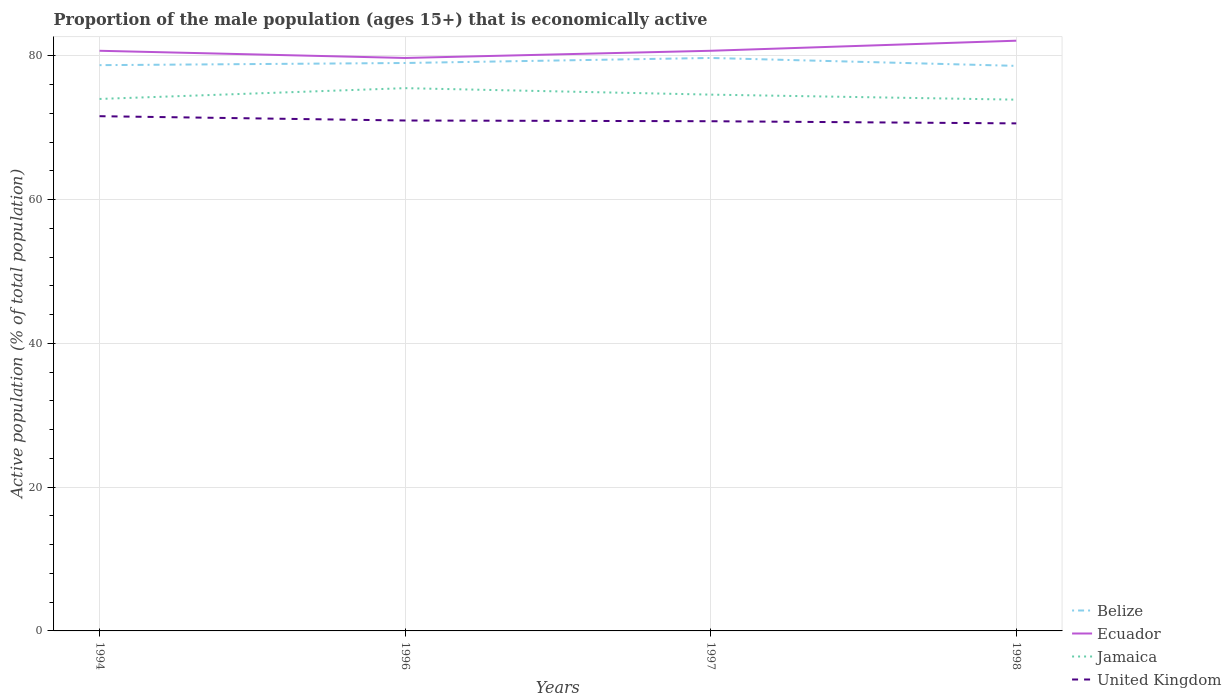How many different coloured lines are there?
Your answer should be compact. 4. Does the line corresponding to Belize intersect with the line corresponding to United Kingdom?
Ensure brevity in your answer.  No. Across all years, what is the maximum proportion of the male population that is economically active in Ecuador?
Offer a terse response. 79.7. In which year was the proportion of the male population that is economically active in Jamaica maximum?
Your answer should be compact. 1998. What is the total proportion of the male population that is economically active in Jamaica in the graph?
Provide a succinct answer. 0.1. What is the difference between the highest and the second highest proportion of the male population that is economically active in Belize?
Keep it short and to the point. 1.1. What is the difference between the highest and the lowest proportion of the male population that is economically active in Ecuador?
Your response must be concise. 1. Is the proportion of the male population that is economically active in Jamaica strictly greater than the proportion of the male population that is economically active in Ecuador over the years?
Your response must be concise. Yes. Are the values on the major ticks of Y-axis written in scientific E-notation?
Your answer should be very brief. No. Does the graph contain any zero values?
Offer a terse response. No. How are the legend labels stacked?
Offer a very short reply. Vertical. What is the title of the graph?
Make the answer very short. Proportion of the male population (ages 15+) that is economically active. What is the label or title of the Y-axis?
Your response must be concise. Active population (% of total population). What is the Active population (% of total population) in Belize in 1994?
Your answer should be compact. 78.7. What is the Active population (% of total population) of Ecuador in 1994?
Offer a very short reply. 80.7. What is the Active population (% of total population) in Jamaica in 1994?
Give a very brief answer. 74. What is the Active population (% of total population) in United Kingdom in 1994?
Keep it short and to the point. 71.6. What is the Active population (% of total population) of Belize in 1996?
Offer a very short reply. 79. What is the Active population (% of total population) of Ecuador in 1996?
Offer a terse response. 79.7. What is the Active population (% of total population) of Jamaica in 1996?
Offer a terse response. 75.5. What is the Active population (% of total population) in Belize in 1997?
Provide a succinct answer. 79.7. What is the Active population (% of total population) in Ecuador in 1997?
Provide a succinct answer. 80.7. What is the Active population (% of total population) in Jamaica in 1997?
Ensure brevity in your answer.  74.6. What is the Active population (% of total population) of United Kingdom in 1997?
Provide a short and direct response. 70.9. What is the Active population (% of total population) in Belize in 1998?
Offer a terse response. 78.6. What is the Active population (% of total population) in Ecuador in 1998?
Your answer should be very brief. 82.1. What is the Active population (% of total population) of Jamaica in 1998?
Offer a very short reply. 73.9. What is the Active population (% of total population) of United Kingdom in 1998?
Offer a very short reply. 70.6. Across all years, what is the maximum Active population (% of total population) of Belize?
Offer a terse response. 79.7. Across all years, what is the maximum Active population (% of total population) of Ecuador?
Your response must be concise. 82.1. Across all years, what is the maximum Active population (% of total population) in Jamaica?
Offer a very short reply. 75.5. Across all years, what is the maximum Active population (% of total population) of United Kingdom?
Give a very brief answer. 71.6. Across all years, what is the minimum Active population (% of total population) in Belize?
Your answer should be very brief. 78.6. Across all years, what is the minimum Active population (% of total population) of Ecuador?
Your answer should be very brief. 79.7. Across all years, what is the minimum Active population (% of total population) in Jamaica?
Make the answer very short. 73.9. Across all years, what is the minimum Active population (% of total population) of United Kingdom?
Your answer should be very brief. 70.6. What is the total Active population (% of total population) in Belize in the graph?
Keep it short and to the point. 316. What is the total Active population (% of total population) of Ecuador in the graph?
Provide a short and direct response. 323.2. What is the total Active population (% of total population) of Jamaica in the graph?
Make the answer very short. 298. What is the total Active population (% of total population) in United Kingdom in the graph?
Offer a very short reply. 284.1. What is the difference between the Active population (% of total population) in Belize in 1994 and that in 1996?
Provide a short and direct response. -0.3. What is the difference between the Active population (% of total population) in Jamaica in 1994 and that in 1996?
Offer a terse response. -1.5. What is the difference between the Active population (% of total population) of United Kingdom in 1994 and that in 1996?
Provide a short and direct response. 0.6. What is the difference between the Active population (% of total population) in Ecuador in 1994 and that in 1997?
Your answer should be compact. 0. What is the difference between the Active population (% of total population) in Jamaica in 1994 and that in 1997?
Offer a very short reply. -0.6. What is the difference between the Active population (% of total population) of United Kingdom in 1994 and that in 1998?
Your answer should be very brief. 1. What is the difference between the Active population (% of total population) in Belize in 1996 and that in 1997?
Your response must be concise. -0.7. What is the difference between the Active population (% of total population) in Jamaica in 1996 and that in 1997?
Keep it short and to the point. 0.9. What is the difference between the Active population (% of total population) of Belize in 1996 and that in 1998?
Provide a short and direct response. 0.4. What is the difference between the Active population (% of total population) of Ecuador in 1996 and that in 1998?
Ensure brevity in your answer.  -2.4. What is the difference between the Active population (% of total population) of United Kingdom in 1996 and that in 1998?
Ensure brevity in your answer.  0.4. What is the difference between the Active population (% of total population) of Belize in 1997 and that in 1998?
Ensure brevity in your answer.  1.1. What is the difference between the Active population (% of total population) in Jamaica in 1997 and that in 1998?
Keep it short and to the point. 0.7. What is the difference between the Active population (% of total population) in United Kingdom in 1997 and that in 1998?
Ensure brevity in your answer.  0.3. What is the difference between the Active population (% of total population) of Belize in 1994 and the Active population (% of total population) of United Kingdom in 1996?
Provide a short and direct response. 7.7. What is the difference between the Active population (% of total population) in Jamaica in 1994 and the Active population (% of total population) in United Kingdom in 1996?
Your answer should be very brief. 3. What is the difference between the Active population (% of total population) in Belize in 1994 and the Active population (% of total population) in United Kingdom in 1997?
Your response must be concise. 7.8. What is the difference between the Active population (% of total population) of Jamaica in 1994 and the Active population (% of total population) of United Kingdom in 1997?
Provide a succinct answer. 3.1. What is the difference between the Active population (% of total population) of Belize in 1994 and the Active population (% of total population) of Ecuador in 1998?
Give a very brief answer. -3.4. What is the difference between the Active population (% of total population) in Ecuador in 1994 and the Active population (% of total population) in United Kingdom in 1998?
Ensure brevity in your answer.  10.1. What is the difference between the Active population (% of total population) of Belize in 1996 and the Active population (% of total population) of Jamaica in 1997?
Offer a terse response. 4.4. What is the difference between the Active population (% of total population) in Belize in 1996 and the Active population (% of total population) in United Kingdom in 1997?
Your response must be concise. 8.1. What is the difference between the Active population (% of total population) in Ecuador in 1996 and the Active population (% of total population) in United Kingdom in 1997?
Ensure brevity in your answer.  8.8. What is the difference between the Active population (% of total population) in Belize in 1996 and the Active population (% of total population) in Jamaica in 1998?
Your response must be concise. 5.1. What is the difference between the Active population (% of total population) in Belize in 1996 and the Active population (% of total population) in United Kingdom in 1998?
Offer a very short reply. 8.4. What is the difference between the Active population (% of total population) of Ecuador in 1996 and the Active population (% of total population) of United Kingdom in 1998?
Offer a very short reply. 9.1. What is the difference between the Active population (% of total population) of Belize in 1997 and the Active population (% of total population) of Ecuador in 1998?
Make the answer very short. -2.4. What is the difference between the Active population (% of total population) in Belize in 1997 and the Active population (% of total population) in Jamaica in 1998?
Make the answer very short. 5.8. What is the difference between the Active population (% of total population) in Ecuador in 1997 and the Active population (% of total population) in Jamaica in 1998?
Your answer should be compact. 6.8. What is the difference between the Active population (% of total population) of Jamaica in 1997 and the Active population (% of total population) of United Kingdom in 1998?
Your response must be concise. 4. What is the average Active population (% of total population) in Belize per year?
Provide a succinct answer. 79. What is the average Active population (% of total population) of Ecuador per year?
Offer a terse response. 80.8. What is the average Active population (% of total population) of Jamaica per year?
Offer a terse response. 74.5. What is the average Active population (% of total population) in United Kingdom per year?
Ensure brevity in your answer.  71.03. In the year 1994, what is the difference between the Active population (% of total population) in Belize and Active population (% of total population) in Ecuador?
Make the answer very short. -2. In the year 1994, what is the difference between the Active population (% of total population) in Belize and Active population (% of total population) in Jamaica?
Ensure brevity in your answer.  4.7. In the year 1994, what is the difference between the Active population (% of total population) of Jamaica and Active population (% of total population) of United Kingdom?
Give a very brief answer. 2.4. In the year 1996, what is the difference between the Active population (% of total population) of Belize and Active population (% of total population) of Ecuador?
Offer a terse response. -0.7. In the year 1996, what is the difference between the Active population (% of total population) in Belize and Active population (% of total population) in Jamaica?
Ensure brevity in your answer.  3.5. In the year 1996, what is the difference between the Active population (% of total population) in Belize and Active population (% of total population) in United Kingdom?
Give a very brief answer. 8. In the year 1996, what is the difference between the Active population (% of total population) of Ecuador and Active population (% of total population) of Jamaica?
Make the answer very short. 4.2. In the year 1996, what is the difference between the Active population (% of total population) of Ecuador and Active population (% of total population) of United Kingdom?
Give a very brief answer. 8.7. In the year 1996, what is the difference between the Active population (% of total population) of Jamaica and Active population (% of total population) of United Kingdom?
Give a very brief answer. 4.5. In the year 1997, what is the difference between the Active population (% of total population) in Belize and Active population (% of total population) in Jamaica?
Provide a succinct answer. 5.1. In the year 1997, what is the difference between the Active population (% of total population) in Belize and Active population (% of total population) in United Kingdom?
Your answer should be very brief. 8.8. In the year 1997, what is the difference between the Active population (% of total population) in Ecuador and Active population (% of total population) in Jamaica?
Give a very brief answer. 6.1. In the year 1997, what is the difference between the Active population (% of total population) in Jamaica and Active population (% of total population) in United Kingdom?
Provide a succinct answer. 3.7. In the year 1998, what is the difference between the Active population (% of total population) of Belize and Active population (% of total population) of Ecuador?
Make the answer very short. -3.5. In the year 1998, what is the difference between the Active population (% of total population) of Jamaica and Active population (% of total population) of United Kingdom?
Offer a very short reply. 3.3. What is the ratio of the Active population (% of total population) of Belize in 1994 to that in 1996?
Ensure brevity in your answer.  1. What is the ratio of the Active population (% of total population) in Ecuador in 1994 to that in 1996?
Your answer should be very brief. 1.01. What is the ratio of the Active population (% of total population) of Jamaica in 1994 to that in 1996?
Give a very brief answer. 0.98. What is the ratio of the Active population (% of total population) in United Kingdom in 1994 to that in 1996?
Provide a short and direct response. 1.01. What is the ratio of the Active population (% of total population) in Belize in 1994 to that in 1997?
Offer a very short reply. 0.99. What is the ratio of the Active population (% of total population) in Ecuador in 1994 to that in 1997?
Offer a terse response. 1. What is the ratio of the Active population (% of total population) of Jamaica in 1994 to that in 1997?
Keep it short and to the point. 0.99. What is the ratio of the Active population (% of total population) of United Kingdom in 1994 to that in 1997?
Your answer should be very brief. 1.01. What is the ratio of the Active population (% of total population) in Belize in 1994 to that in 1998?
Your response must be concise. 1. What is the ratio of the Active population (% of total population) in Ecuador in 1994 to that in 1998?
Ensure brevity in your answer.  0.98. What is the ratio of the Active population (% of total population) of Jamaica in 1994 to that in 1998?
Make the answer very short. 1. What is the ratio of the Active population (% of total population) of United Kingdom in 1994 to that in 1998?
Give a very brief answer. 1.01. What is the ratio of the Active population (% of total population) of Ecuador in 1996 to that in 1997?
Keep it short and to the point. 0.99. What is the ratio of the Active population (% of total population) in Jamaica in 1996 to that in 1997?
Ensure brevity in your answer.  1.01. What is the ratio of the Active population (% of total population) in United Kingdom in 1996 to that in 1997?
Give a very brief answer. 1. What is the ratio of the Active population (% of total population) in Ecuador in 1996 to that in 1998?
Your answer should be very brief. 0.97. What is the ratio of the Active population (% of total population) of Jamaica in 1996 to that in 1998?
Offer a very short reply. 1.02. What is the ratio of the Active population (% of total population) in United Kingdom in 1996 to that in 1998?
Your response must be concise. 1.01. What is the ratio of the Active population (% of total population) in Belize in 1997 to that in 1998?
Keep it short and to the point. 1.01. What is the ratio of the Active population (% of total population) in Ecuador in 1997 to that in 1998?
Offer a terse response. 0.98. What is the ratio of the Active population (% of total population) in Jamaica in 1997 to that in 1998?
Provide a short and direct response. 1.01. What is the ratio of the Active population (% of total population) of United Kingdom in 1997 to that in 1998?
Offer a very short reply. 1. What is the difference between the highest and the second highest Active population (% of total population) in Belize?
Your response must be concise. 0.7. What is the difference between the highest and the lowest Active population (% of total population) of Belize?
Your answer should be compact. 1.1. What is the difference between the highest and the lowest Active population (% of total population) of Ecuador?
Offer a terse response. 2.4. What is the difference between the highest and the lowest Active population (% of total population) in United Kingdom?
Provide a succinct answer. 1. 